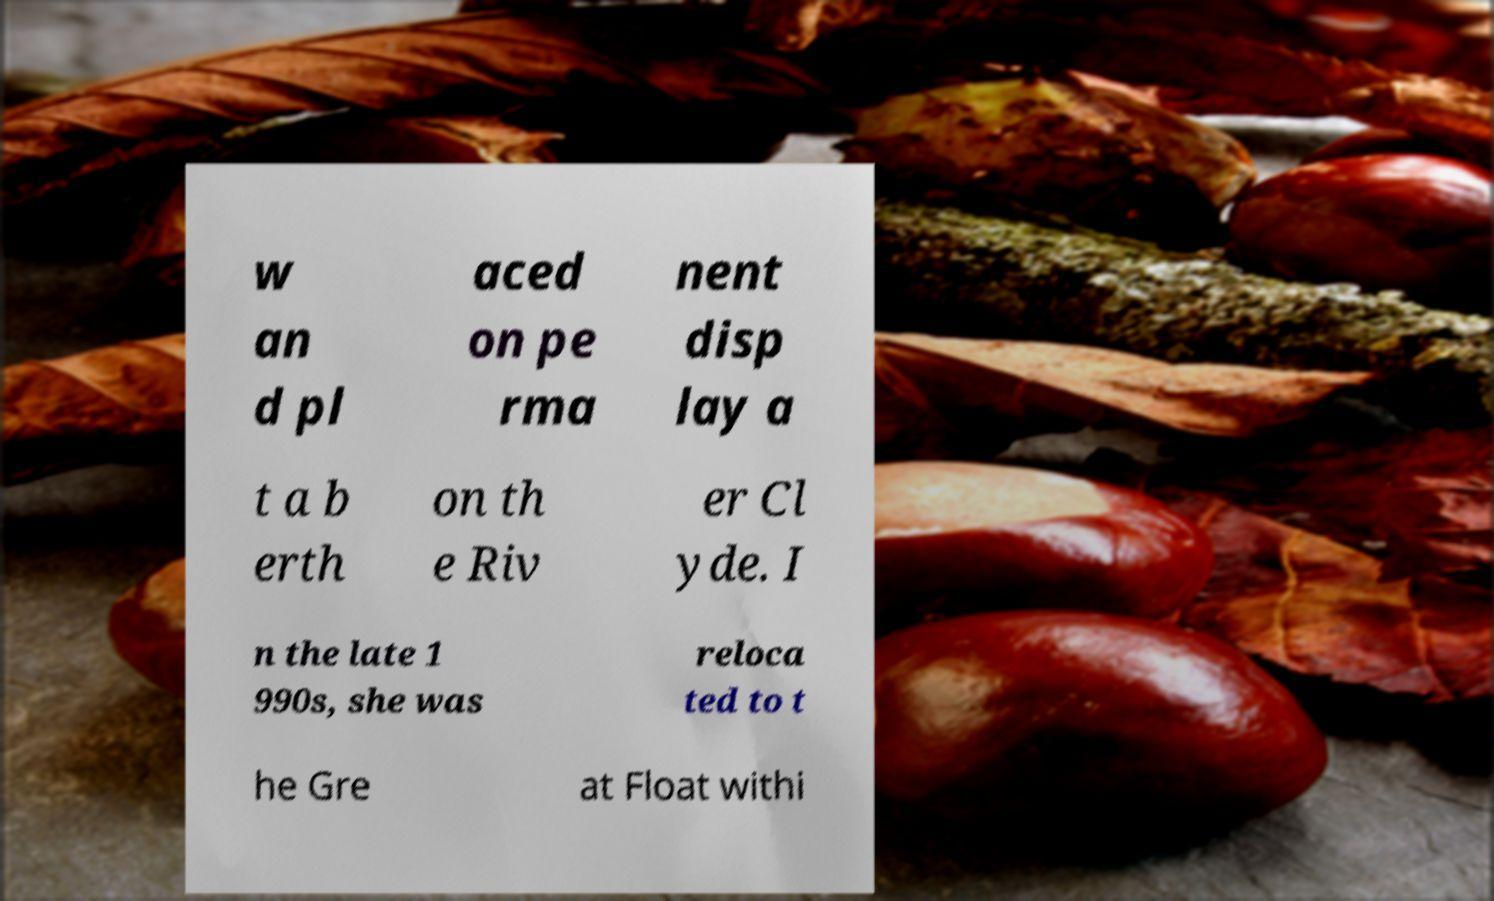For documentation purposes, I need the text within this image transcribed. Could you provide that? w an d pl aced on pe rma nent disp lay a t a b erth on th e Riv er Cl yde. I n the late 1 990s, she was reloca ted to t he Gre at Float withi 